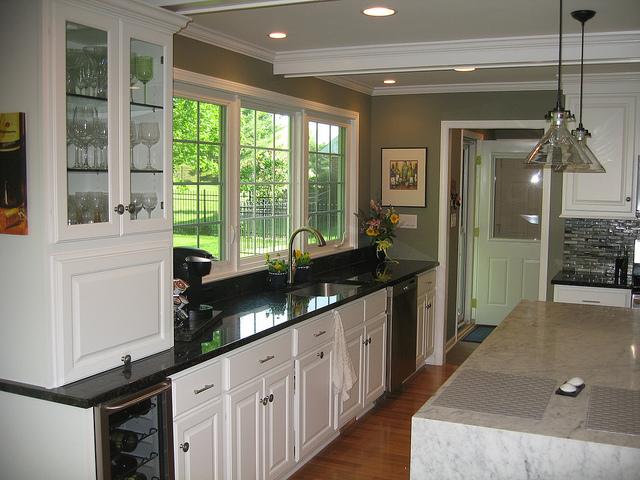Is this room a living room?
Answer briefly. No. What is in the appliance on the bottom left?
Be succinct. Fridge. What is the island surface made of?
Keep it brief. Marble. 